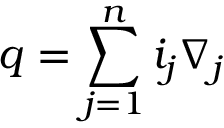<formula> <loc_0><loc_0><loc_500><loc_500>q = \sum _ { j = 1 } ^ { n } { i _ { j } \nabla _ { j } }</formula> 